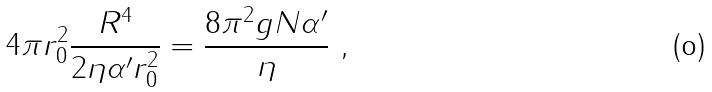Convert formula to latex. <formula><loc_0><loc_0><loc_500><loc_500>4 \pi r _ { 0 } ^ { 2 } \frac { R ^ { 4 } } { 2 \eta \alpha ^ { \prime } r _ { 0 } ^ { 2 } } = \frac { 8 \pi ^ { 2 } g N \alpha ^ { \prime } } { \eta } \ ,</formula> 